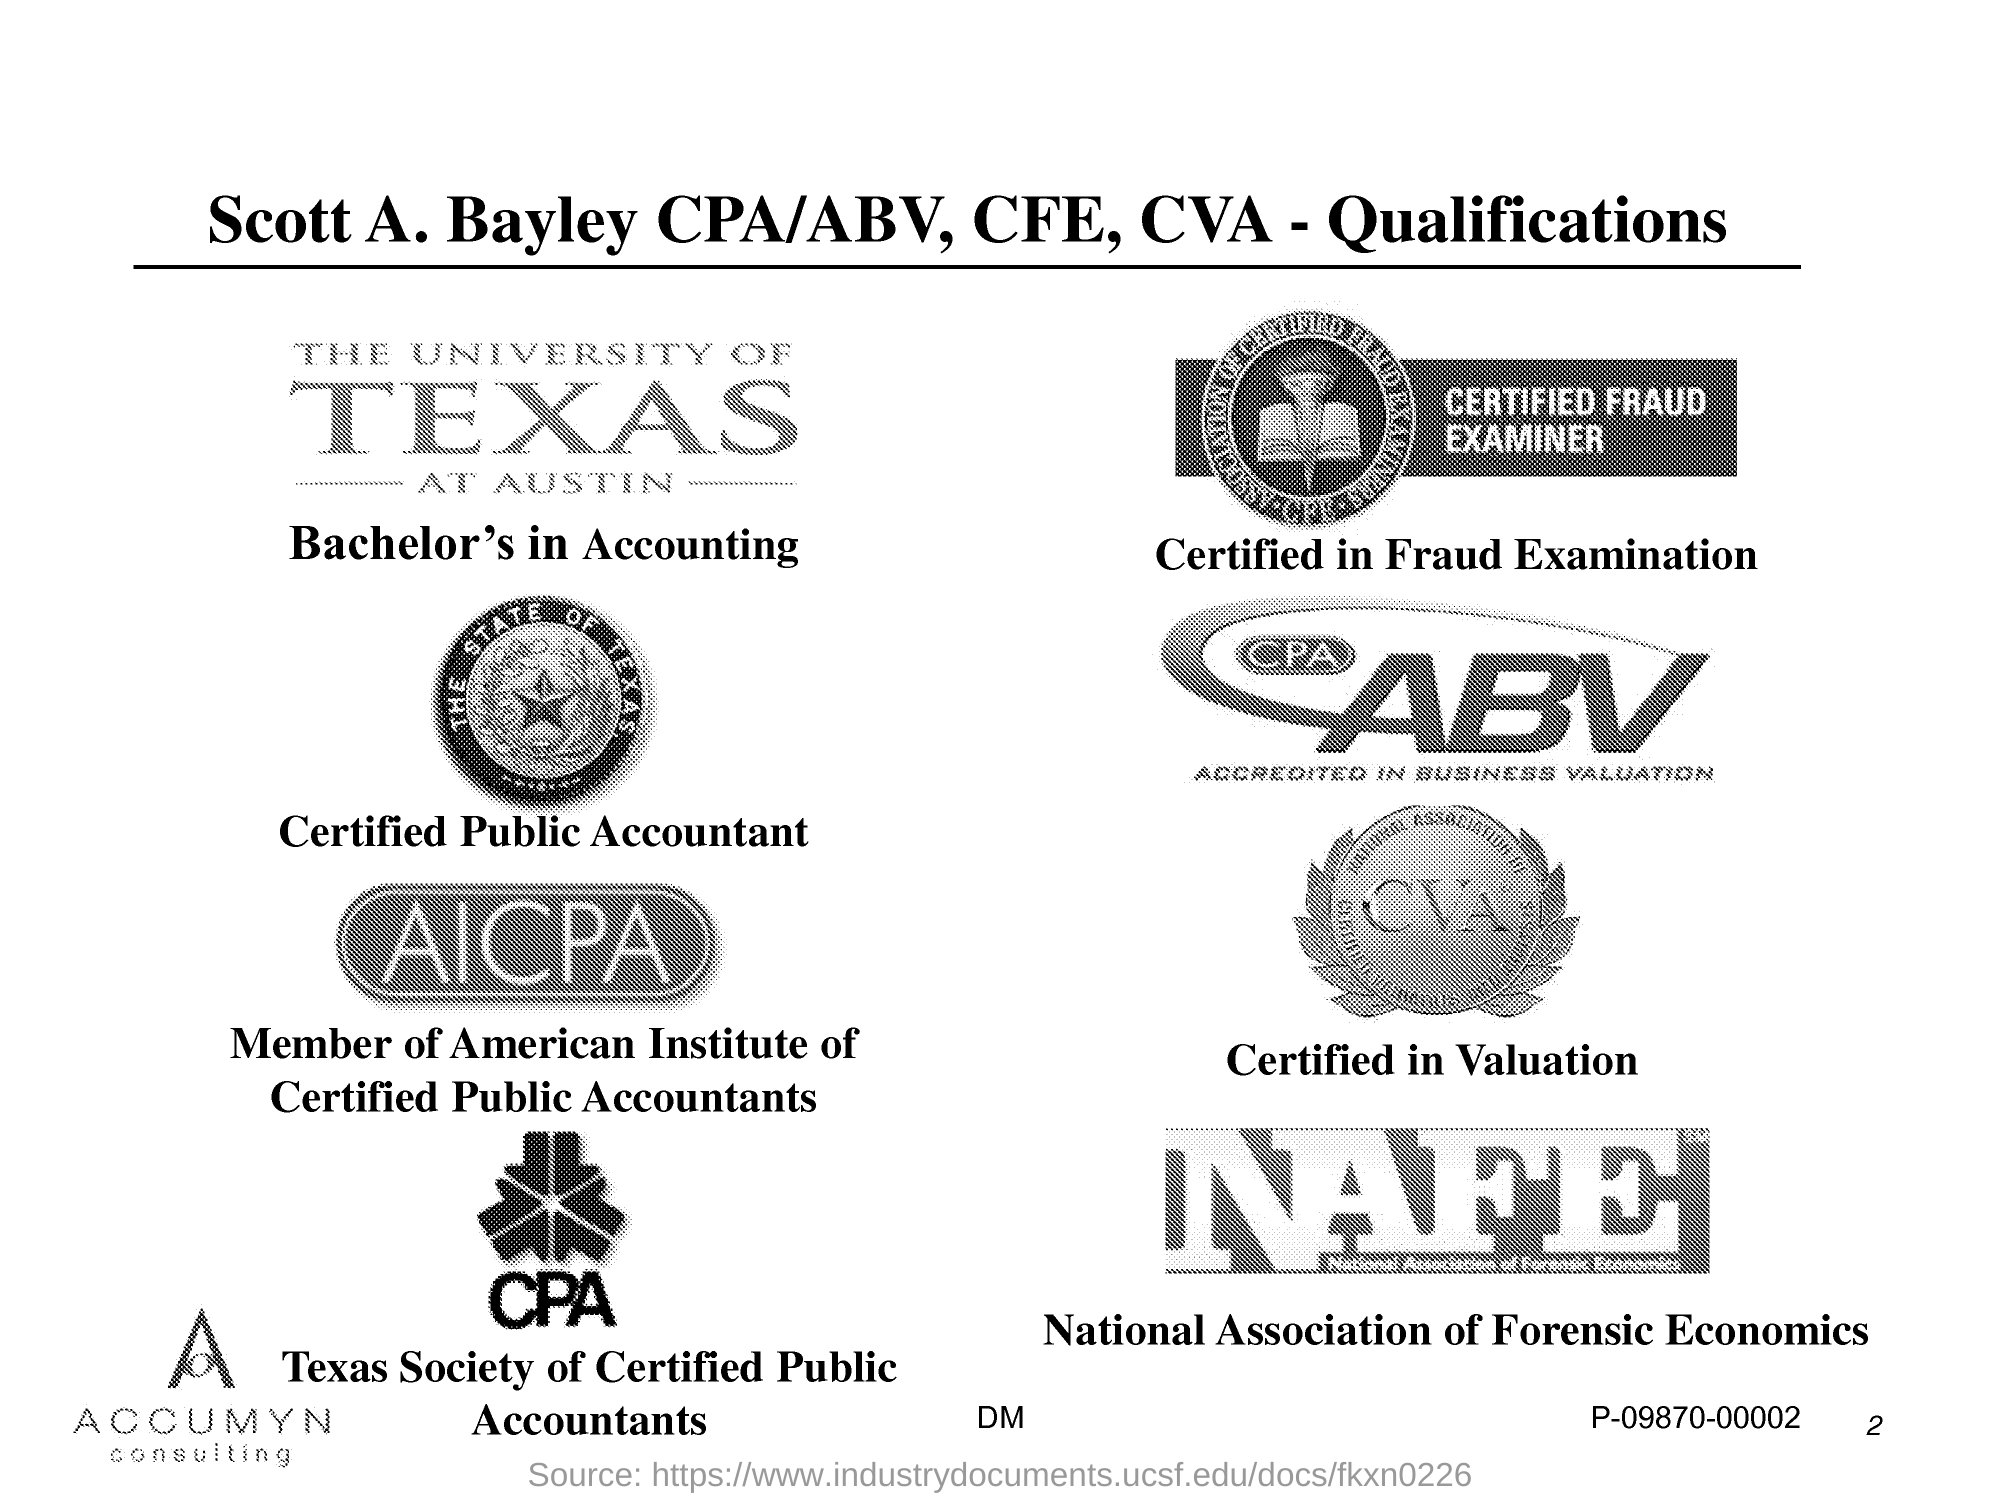What is the fullform of NAFE?
Your answer should be compact. National Association of Forensic economics. 